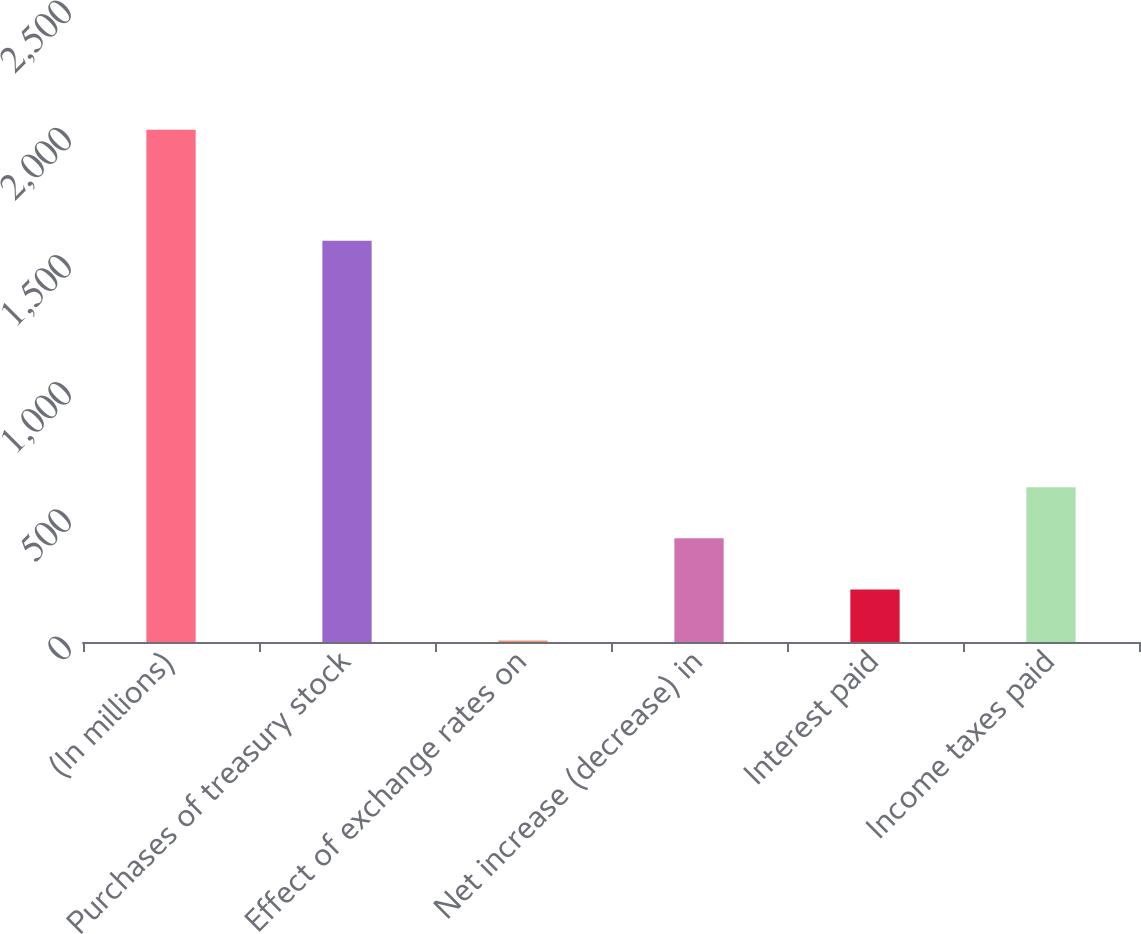Convert chart. <chart><loc_0><loc_0><loc_500><loc_500><bar_chart><fcel>(In millions)<fcel>Purchases of treasury stock<fcel>Effect of exchange rates on<fcel>Net increase (decrease) in<fcel>Interest paid<fcel>Income taxes paid<nl><fcel>2014<fcel>1577<fcel>6<fcel>407.6<fcel>206.8<fcel>608.4<nl></chart> 